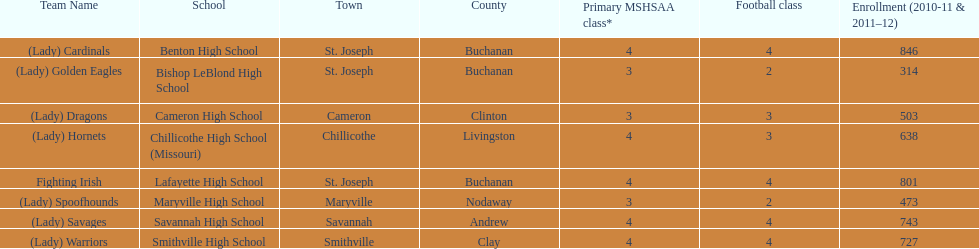Help me parse the entirety of this table. {'header': ['Team Name', 'School', 'Town', 'County', 'Primary MSHSAA class*', 'Football class', 'Enrollment (2010-11 & 2011–12)'], 'rows': [['(Lady) Cardinals', 'Benton High School', 'St. Joseph', 'Buchanan', '4', '4', '846'], ['(Lady) Golden Eagles', 'Bishop LeBlond High School', 'St. Joseph', 'Buchanan', '3', '2', '314'], ['(Lady) Dragons', 'Cameron High School', 'Cameron', 'Clinton', '3', '3', '503'], ['(Lady) Hornets', 'Chillicothe High School (Missouri)', 'Chillicothe', 'Livingston', '4', '3', '638'], ['Fighting Irish', 'Lafayette High School', 'St. Joseph', 'Buchanan', '4', '4', '801'], ['(Lady) Spoofhounds', 'Maryville High School', 'Maryville', 'Nodaway', '3', '2', '473'], ['(Lady) Savages', 'Savannah High School', 'Savannah', 'Andrew', '4', '4', '743'], ['(Lady) Warriors', 'Smithville High School', 'Smithville', 'Clay', '4', '4', '727']]} How many schools are there in this conference? 8. 